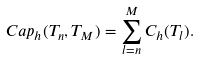<formula> <loc_0><loc_0><loc_500><loc_500>C a p _ { h } ( T _ { n } , T _ { M } ) = \sum _ { l = n } ^ { M } C _ { h } ( T _ { l } ) .</formula> 